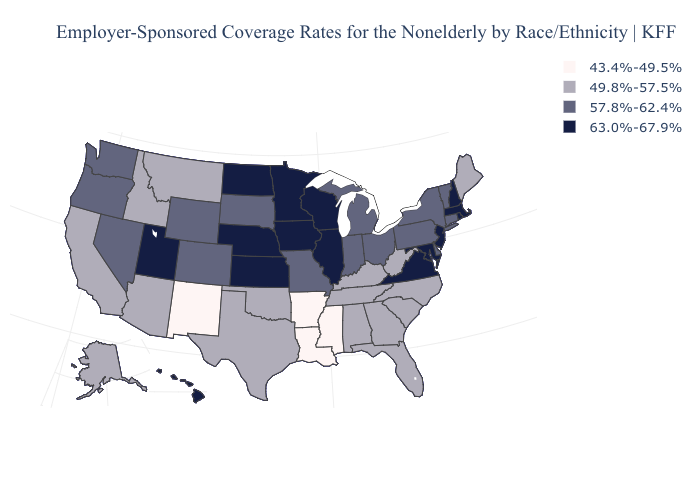What is the lowest value in states that border South Carolina?
Answer briefly. 49.8%-57.5%. Name the states that have a value in the range 63.0%-67.9%?
Quick response, please. Hawaii, Illinois, Iowa, Kansas, Maryland, Massachusetts, Minnesota, Nebraska, New Hampshire, New Jersey, North Dakota, Rhode Island, Utah, Virginia, Wisconsin. What is the lowest value in states that border Arizona?
Concise answer only. 43.4%-49.5%. Does North Carolina have a higher value than Louisiana?
Answer briefly. Yes. How many symbols are there in the legend?
Write a very short answer. 4. Name the states that have a value in the range 57.8%-62.4%?
Be succinct. Colorado, Connecticut, Delaware, Indiana, Michigan, Missouri, Nevada, New York, Ohio, Oregon, Pennsylvania, South Dakota, Vermont, Washington, Wyoming. Name the states that have a value in the range 49.8%-57.5%?
Short answer required. Alabama, Alaska, Arizona, California, Florida, Georgia, Idaho, Kentucky, Maine, Montana, North Carolina, Oklahoma, South Carolina, Tennessee, Texas, West Virginia. Among the states that border California , which have the highest value?
Concise answer only. Nevada, Oregon. Does the map have missing data?
Be succinct. No. What is the highest value in the USA?
Give a very brief answer. 63.0%-67.9%. What is the value of Hawaii?
Write a very short answer. 63.0%-67.9%. Among the states that border Iowa , which have the lowest value?
Answer briefly. Missouri, South Dakota. What is the lowest value in the USA?
Answer briefly. 43.4%-49.5%. Name the states that have a value in the range 57.8%-62.4%?
Keep it brief. Colorado, Connecticut, Delaware, Indiana, Michigan, Missouri, Nevada, New York, Ohio, Oregon, Pennsylvania, South Dakota, Vermont, Washington, Wyoming. What is the value of Minnesota?
Concise answer only. 63.0%-67.9%. 